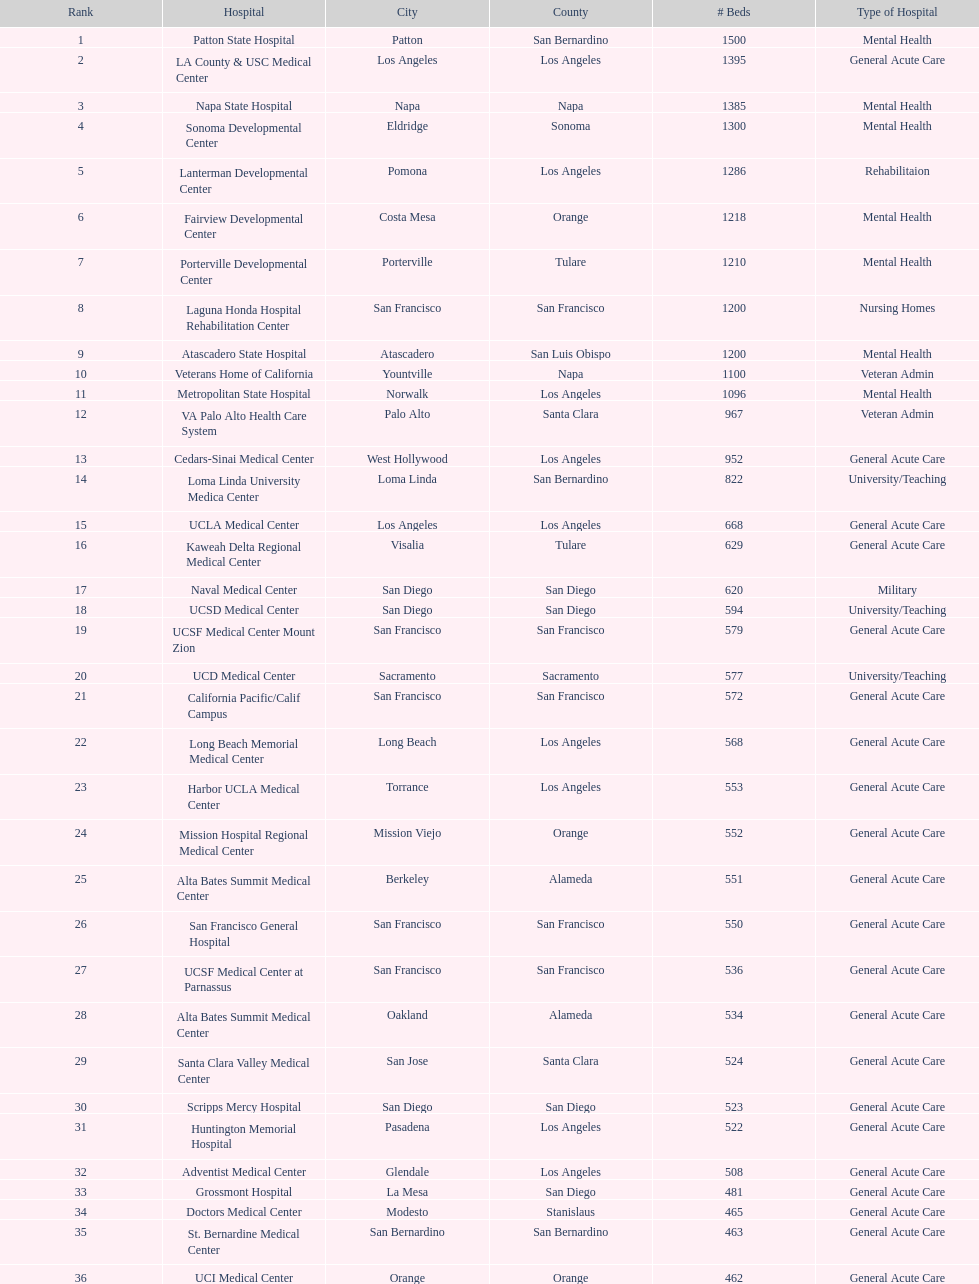How many hospital's have at least 600 beds? 17. 